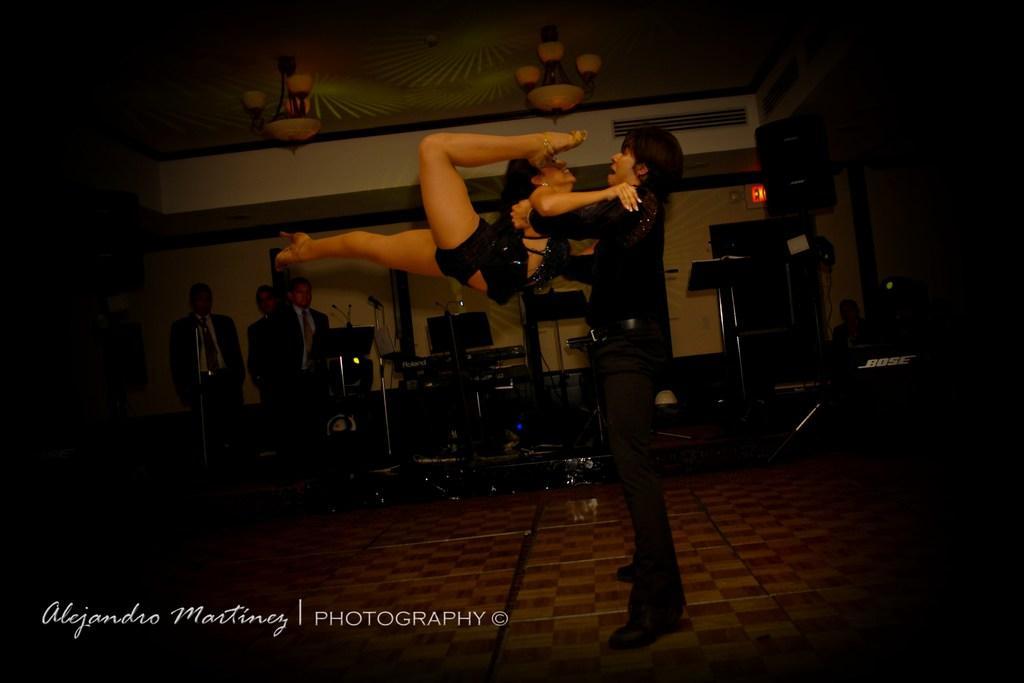Could you give a brief overview of what you see in this image? In the image there is a man lifting a woman and behind them there are few people and music instruments, there is some text at the bottom of the image. 